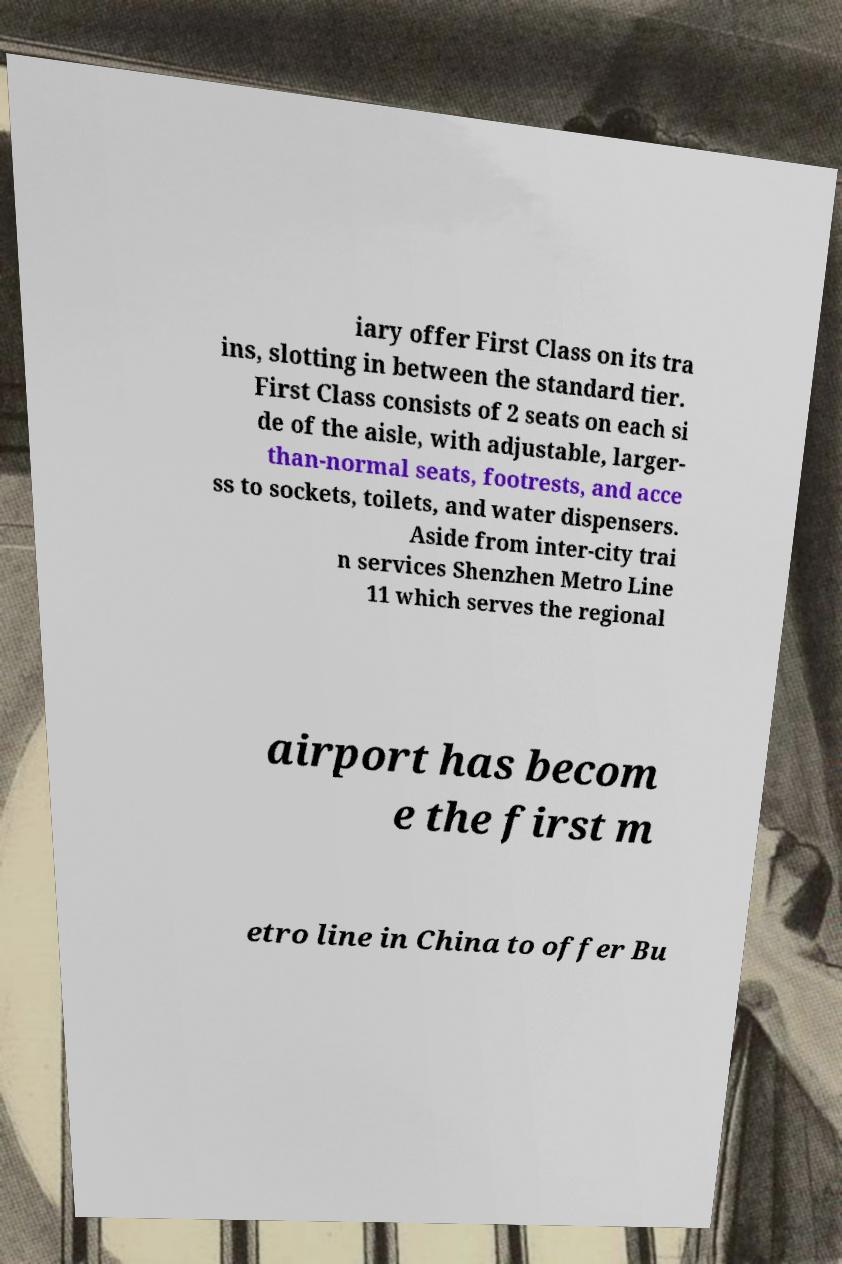What messages or text are displayed in this image? I need them in a readable, typed format. iary offer First Class on its tra ins, slotting in between the standard tier. First Class consists of 2 seats on each si de of the aisle, with adjustable, larger- than-normal seats, footrests, and acce ss to sockets, toilets, and water dispensers. Aside from inter-city trai n services Shenzhen Metro Line 11 which serves the regional airport has becom e the first m etro line in China to offer Bu 